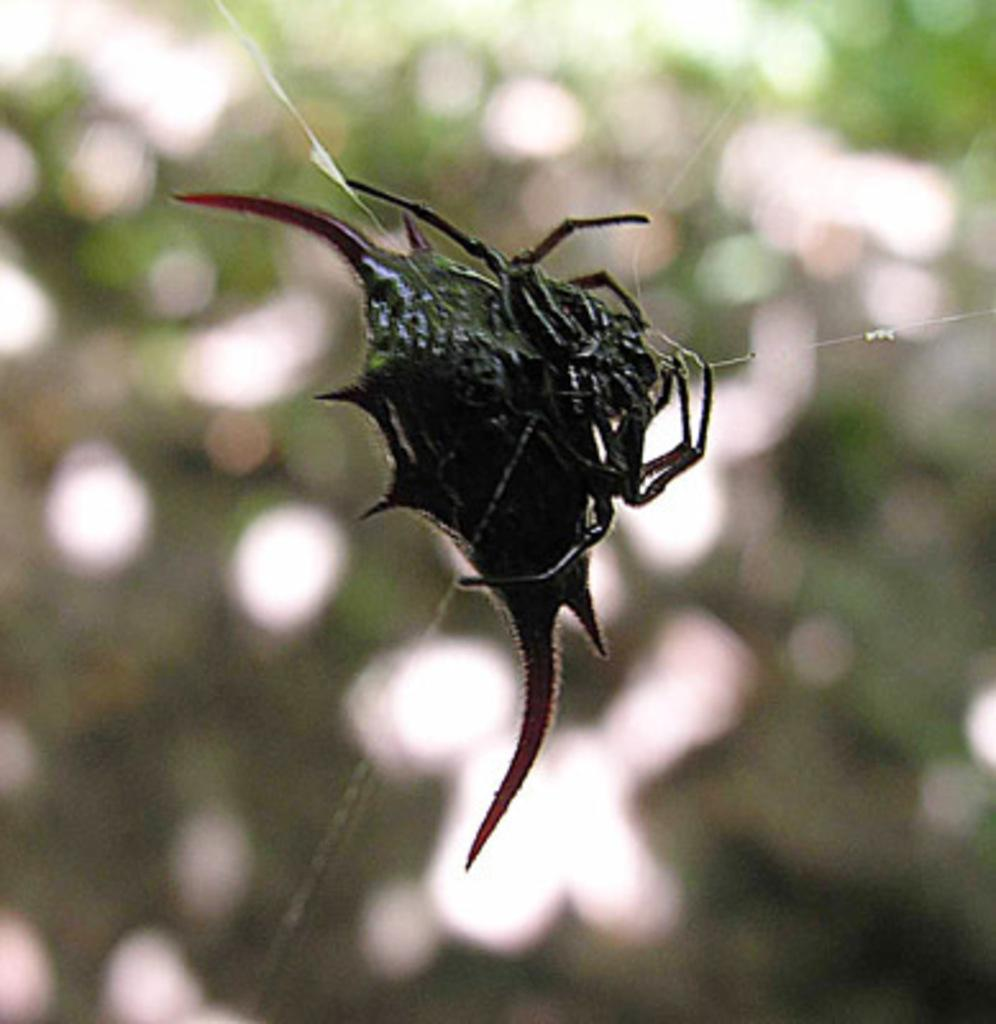What type of creature is present in the image? There is an insect in the image. What color is the insect? The insect is black in color. Can you describe the background of the image? The background of the image is blurred. How far can the insect swim in the image? The insect does not swim in the image, as it is not in a body of water. 